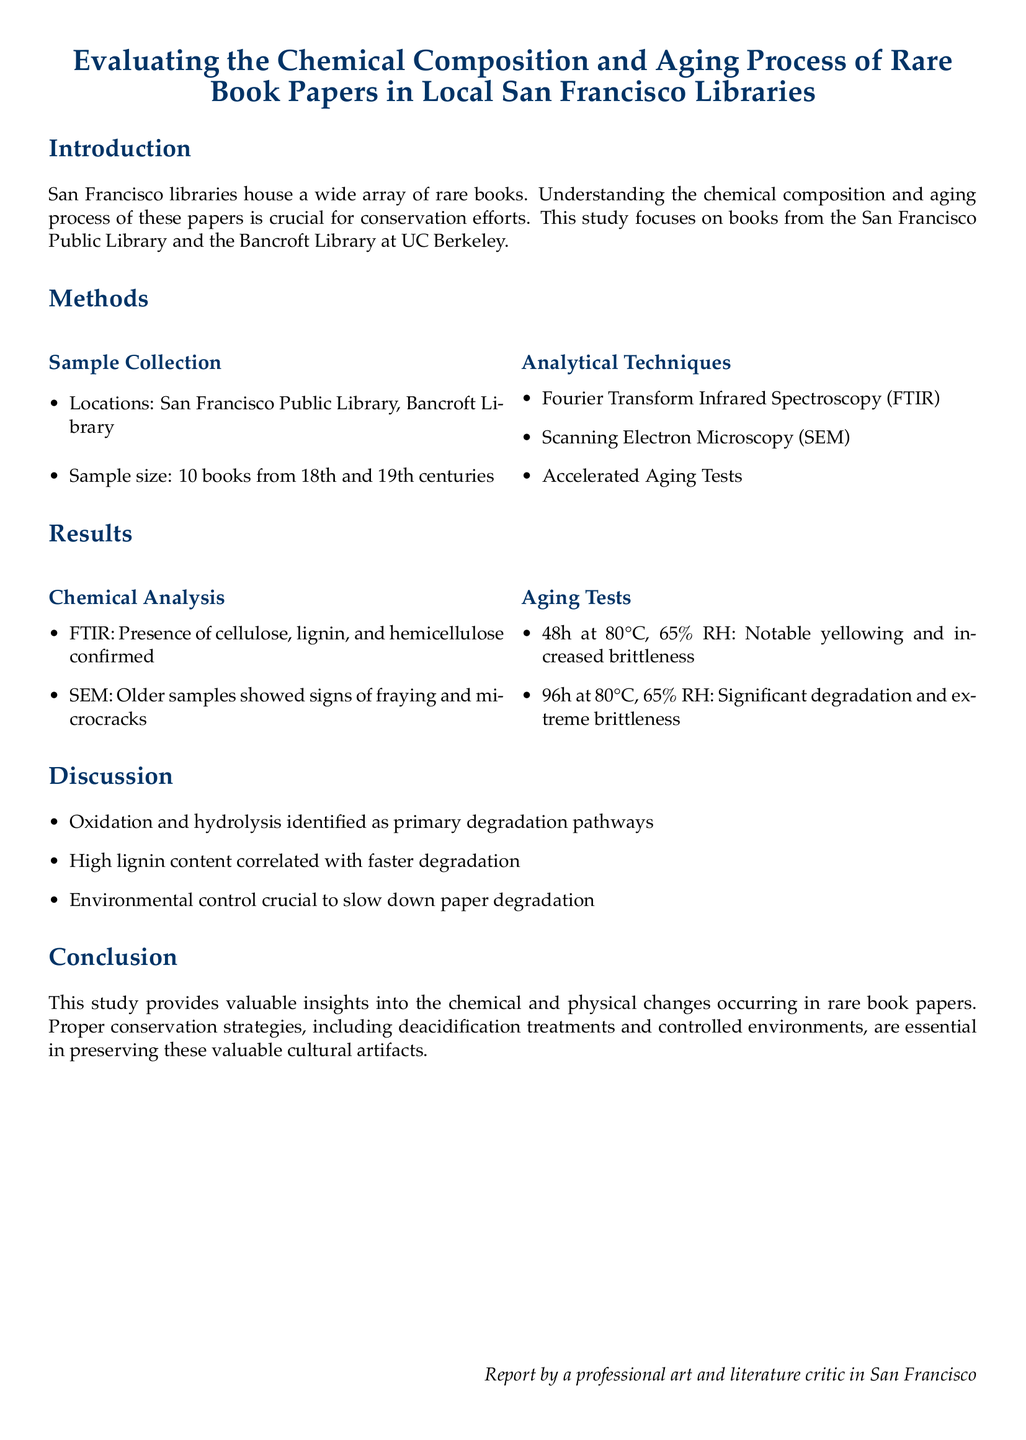What locations were sampled? The locations sampled were specified as San Francisco Public Library and Bancroft Library.
Answer: San Francisco Public Library, Bancroft Library What was the sample size? The sample size mentioned in the document was that 10 books were sampled, specifically from the 18th and 19th centuries.
Answer: 10 books What analytical technique confirmed cellulose presence? The document states that Fourier Transform Infrared Spectroscopy (FTIR) was the technique used to confirm the presence of cellulose.
Answer: Fourier Transform Infrared Spectroscopy What was the temperature used in aging tests? The aging tests were conducted at a temperature of 80 degrees Celsius, as mentioned in the results section.
Answer: 80°C What chemical component correlated with faster degradation? The document specifically states that high lignin content was correlated with faster degradation of the paper samples.
Answer: High lignin content What happened to the papers after 96 hours in aging tests? The results indicate that after 96 hours at the specified conditions, there was significant degradation and extreme brittleness observed in the samples.
Answer: Significant degradation and extreme brittleness What primary degradation pathways were identified? The primary degradation pathways identified include oxidation and hydrolysis, as discussed in the document.
Answer: Oxidation and hydrolysis What is a suggested conservation strategy? The conclusion includes deacidification treatments as one of the suggested conservation strategies to preserve rare book papers.
Answer: Deacidification treatments 